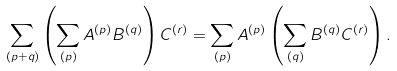<formula> <loc_0><loc_0><loc_500><loc_500>\sum _ { ( p + q ) } \left ( \sum _ { ( p ) } A ^ { ( p ) } B ^ { ( q ) } \right ) C ^ { ( r ) } = \sum _ { ( p ) } A ^ { ( p ) } \left ( \sum _ { ( q ) } B ^ { ( q ) } C ^ { ( r ) } \right ) .</formula> 